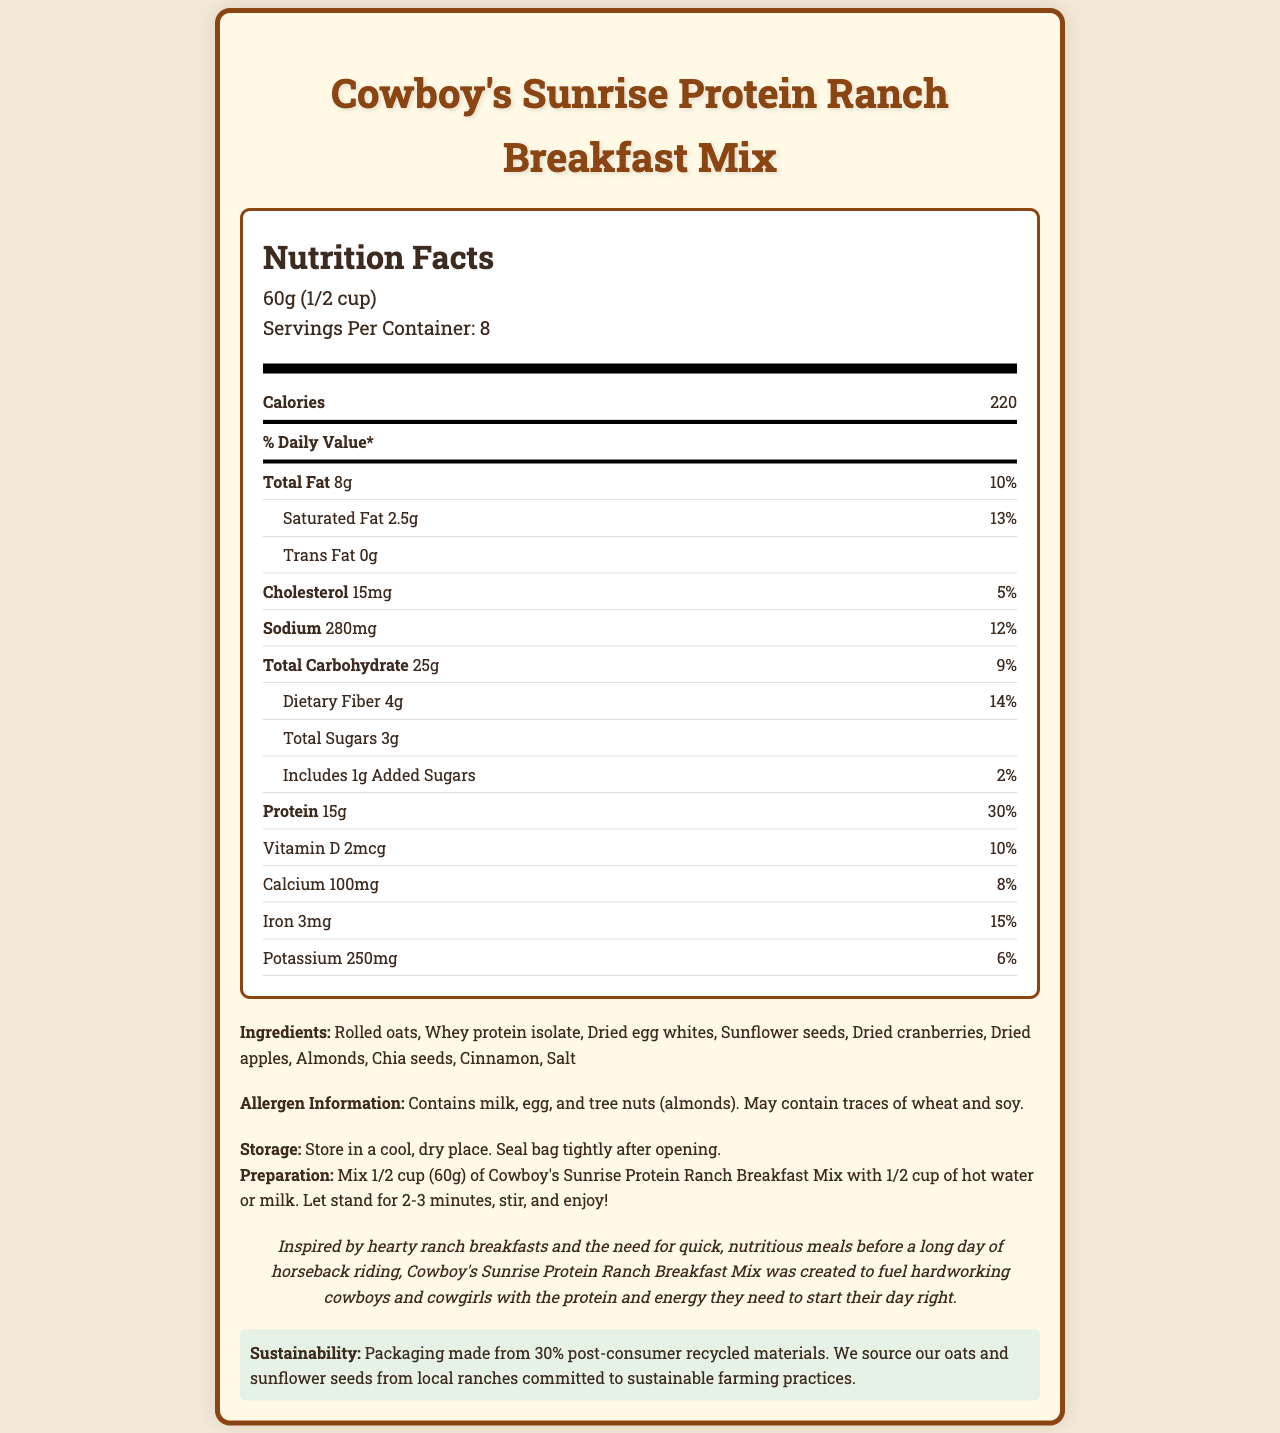what is the serving size? The document specifies that the serving size is 60 grams, which is equivalent to 1/2 cup.
Answer: 60g (1/2 cup) how many calories are there in one serving? The nutritional label states that one serving has 220 calories.
Answer: 220 calories what is the total fat content per serving? The total fat per serving is noted as 8 grams.
Answer: 8g how much protein is in each serving? Each serving contains 15 grams of protein, as indicated on the label.
Answer: 15g what is the % daily value of dietary fiber per serving? The % daily value for dietary fiber is shown as 14%.
Answer: 14% which ingredient is not common in traditional breakfast mixes? A. Rolled oats B. Whey protein isolate C. Chia seeds Chia seeds are less common in traditional breakfast mixes compared to rolled oats and whey protein isolate.
Answer: C. Chia seeds how much cholesterol is there per serving? A. 0mg B. 10mg C. 15mg D. 20mg The document specifies that there are 15 milligrams of cholesterol per serving.
Answer: C. 15mg is there any trans fat in the breakfast mix? The document clearly states that there is 0 grams of trans fat in the breakfast mix.
Answer: No summarize the brand story of this product. The brand story emphasizes the product's inspiration from ranch breakfasts and its aim to provide quick, nutritious meals suitable for active lifestyles, especially for those involved in horseback riding.
Answer: Inspired by hearty ranch breakfasts and quick, nutritious meals, Cowboy's Sunrise Protein Ranch Breakfast Mix was made to fuel hardworking cowboys and cowgirls with essential protein and energy. how much added sugars does the product contain? The document indicates that the product contains 1 gram of added sugars per serving.
Answer: 1g can the document tell us the cost per container? The document does not provide any information regarding the cost per container.
Answer: Cannot be determined what vitamins and minerals are listed, and what are their % daily values? The document lists Vitamin D (10%), Calcium (8%), Iron (15%), and Potassium (6%) with their respective % daily values.
Answer: Vitamin D: 10%, Calcium: 8%, Iron: 15%, Potassium: 6% what are the allergen warnings given? The allergen information provided states that the product contains milk, egg, and tree nuts (almonds) and may contain traces of wheat and soy.
Answer: Contains milk, egg, and tree nuts (almonds). May contain traces of wheat and soy. how should the breakfast mix be stored? The storage instructions recommend keeping the mix in a cool, dry place and sealing the bag tightly after opening.
Answer: Store in a cool, dry place. Seal bag tightly after opening. what sustainability information is provided? The sustainability information indicates the use of 30% post-consumer recycled materials for packaging and highlights the sourcing of oats and sunflower seeds from local sustainable ranches.
Answer: Packaging made from 30% post-consumer recycled materials, and oats and sunflower seeds are sourced from local ranches committed to sustainable farming practices. 